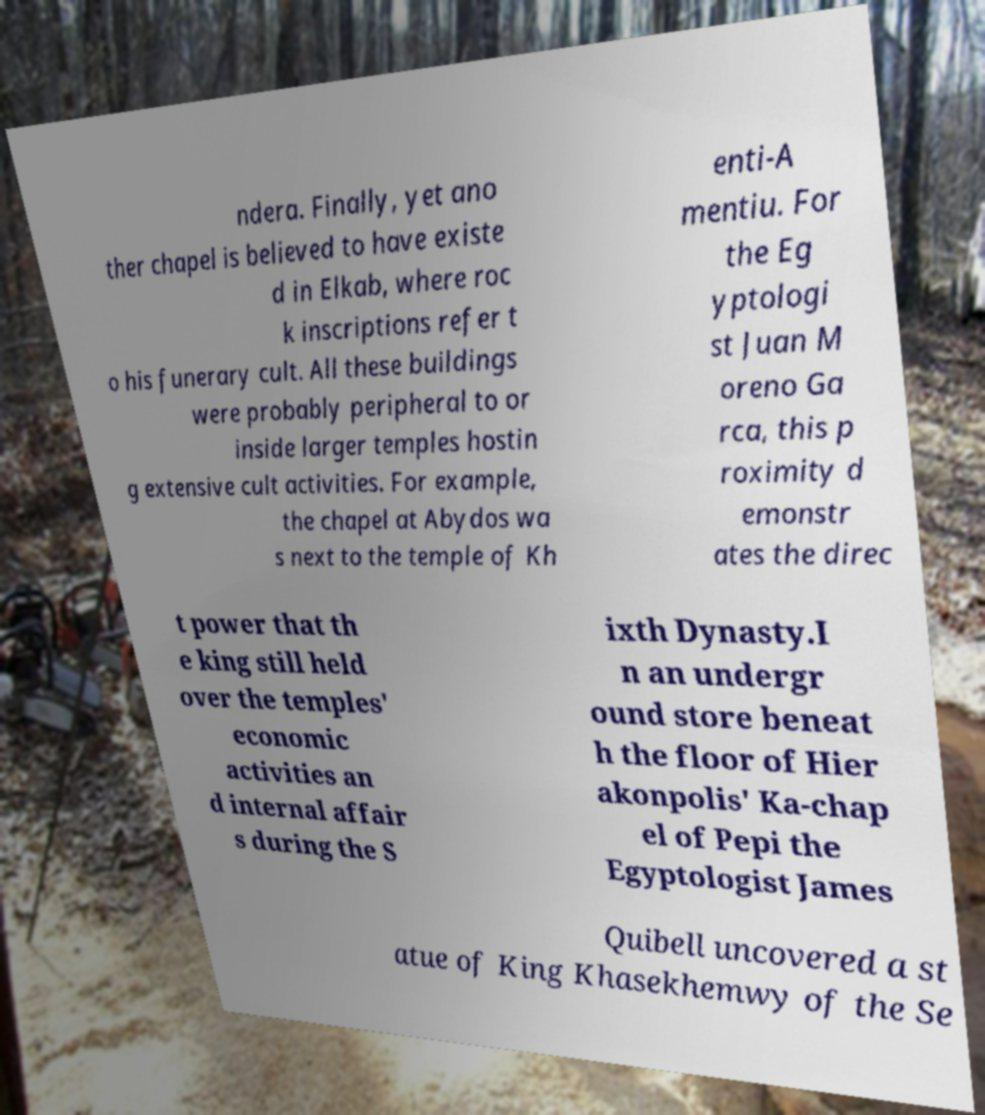For documentation purposes, I need the text within this image transcribed. Could you provide that? ndera. Finally, yet ano ther chapel is believed to have existe d in Elkab, where roc k inscriptions refer t o his funerary cult. All these buildings were probably peripheral to or inside larger temples hostin g extensive cult activities. For example, the chapel at Abydos wa s next to the temple of Kh enti-A mentiu. For the Eg yptologi st Juan M oreno Ga rca, this p roximity d emonstr ates the direc t power that th e king still held over the temples' economic activities an d internal affair s during the S ixth Dynasty.I n an undergr ound store beneat h the floor of Hier akonpolis' Ka-chap el of Pepi the Egyptologist James Quibell uncovered a st atue of King Khasekhemwy of the Se 